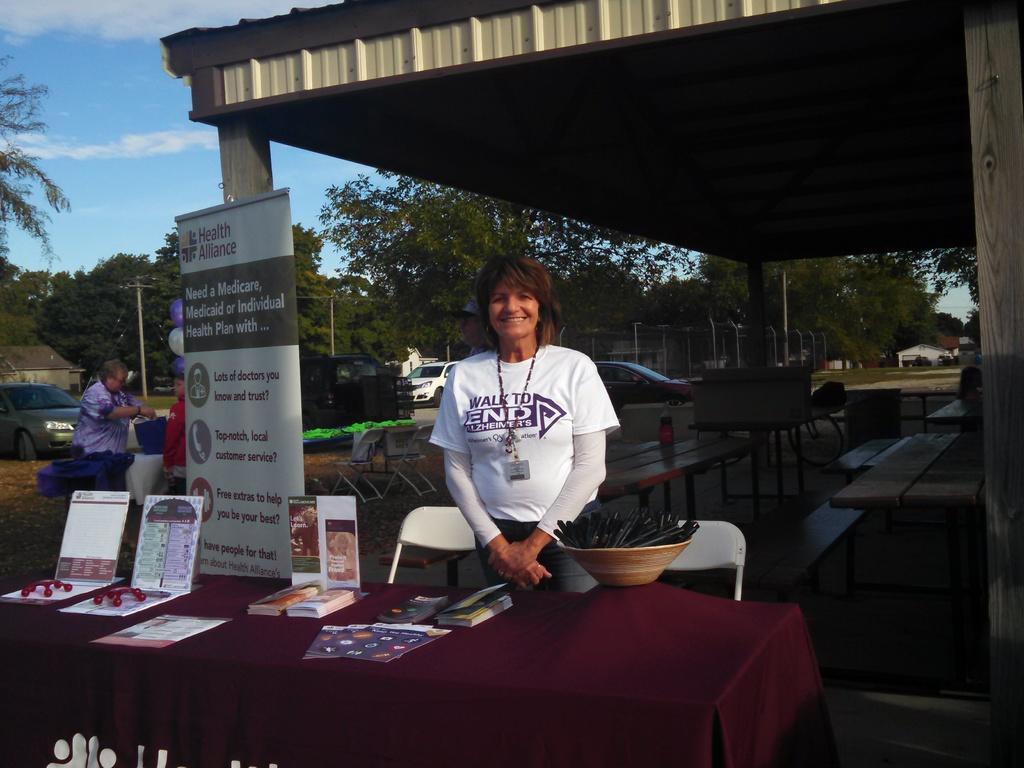Can you describe this image briefly? This image consist of a woman standing in front of a table. The table is covered with a brown cloth on which there are some books , and papers are kept. The woman is wearing white dress. In the background, there are trees, cars, tables and buildings. 